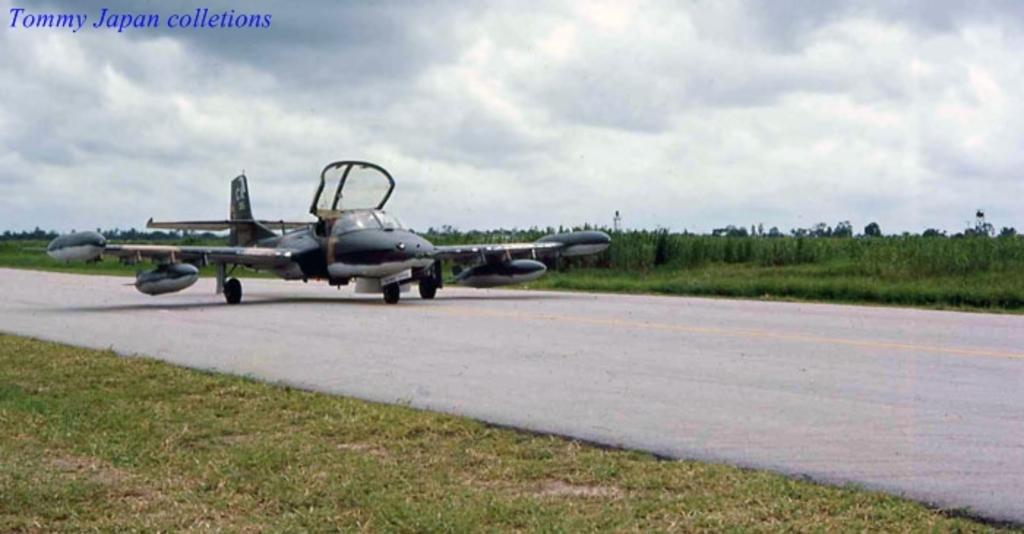What is the main subject of the picture? The main subject of the picture is a jet plane. What can be seen in the background of the picture? There are trees in the picture, and the sky is cloudy. What is present at the top left corner of the picture? There is text at the top left corner of the picture. What type of terrain is visible in the picture? There is grass on the ground in the picture. What type of stone can be seen in the picture? There is no stone present in the picture; it features a jet plane, trees, text, and grass on the ground. 